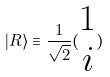<formula> <loc_0><loc_0><loc_500><loc_500>| R \rangle \equiv \frac { 1 } { \sqrt { 2 } } ( \begin{matrix} 1 \\ i \end{matrix} )</formula> 